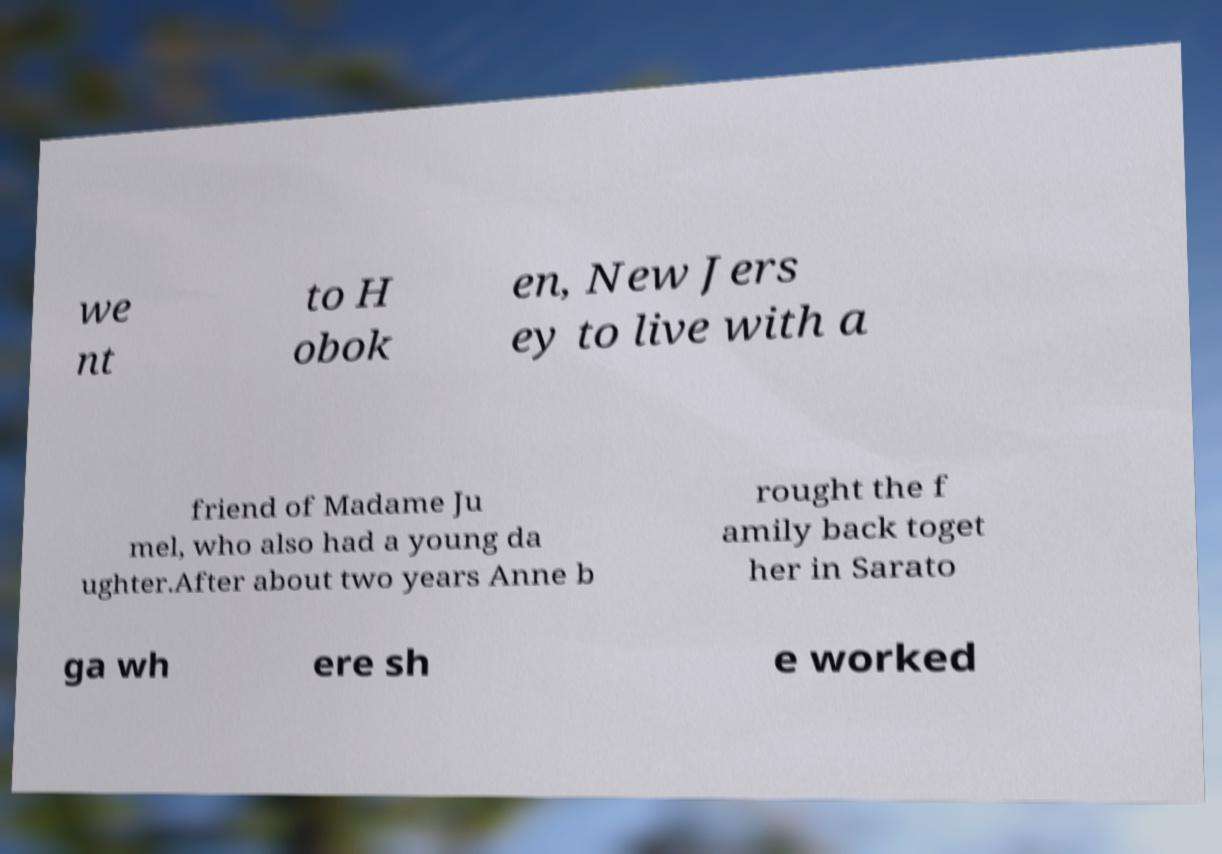For documentation purposes, I need the text within this image transcribed. Could you provide that? we nt to H obok en, New Jers ey to live with a friend of Madame Ju mel, who also had a young da ughter.After about two years Anne b rought the f amily back toget her in Sarato ga wh ere sh e worked 